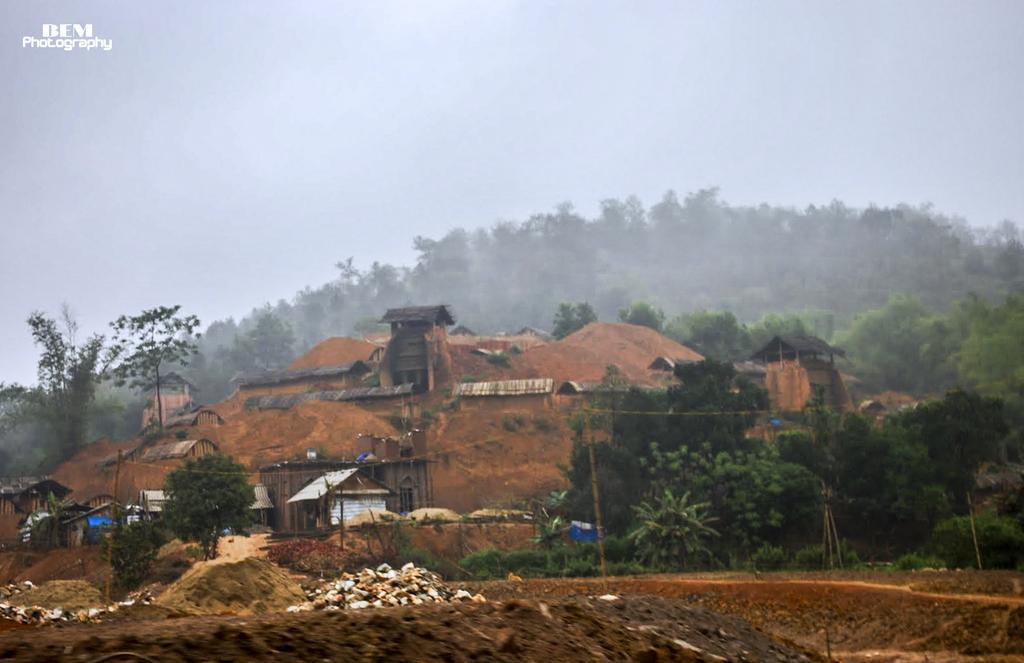What type of natural elements can be seen in the image? There are trees in the image. What type of structures are present in the image? There are huts in the image. What type of geological features can be seen in the image? There are rocks in the image. What type of man-made objects can be seen in the image? There are poles in the image. What type of advertisement can be seen on the trees in the image? There are no advertisements present on the trees in the image; only trees, huts, rocks, and poles are visible. What type of development can be seen in the image? The image does not show any specific development; it only shows trees, huts, rocks, and poles. 